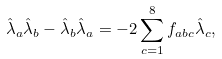Convert formula to latex. <formula><loc_0><loc_0><loc_500><loc_500>\hat { \lambda } _ { a } \hat { \lambda } _ { b } - \hat { \lambda } _ { b } \hat { \lambda } _ { a } = - 2 \sum _ { c = 1 } ^ { 8 } f _ { a b c } \hat { \lambda } _ { c } ,</formula> 